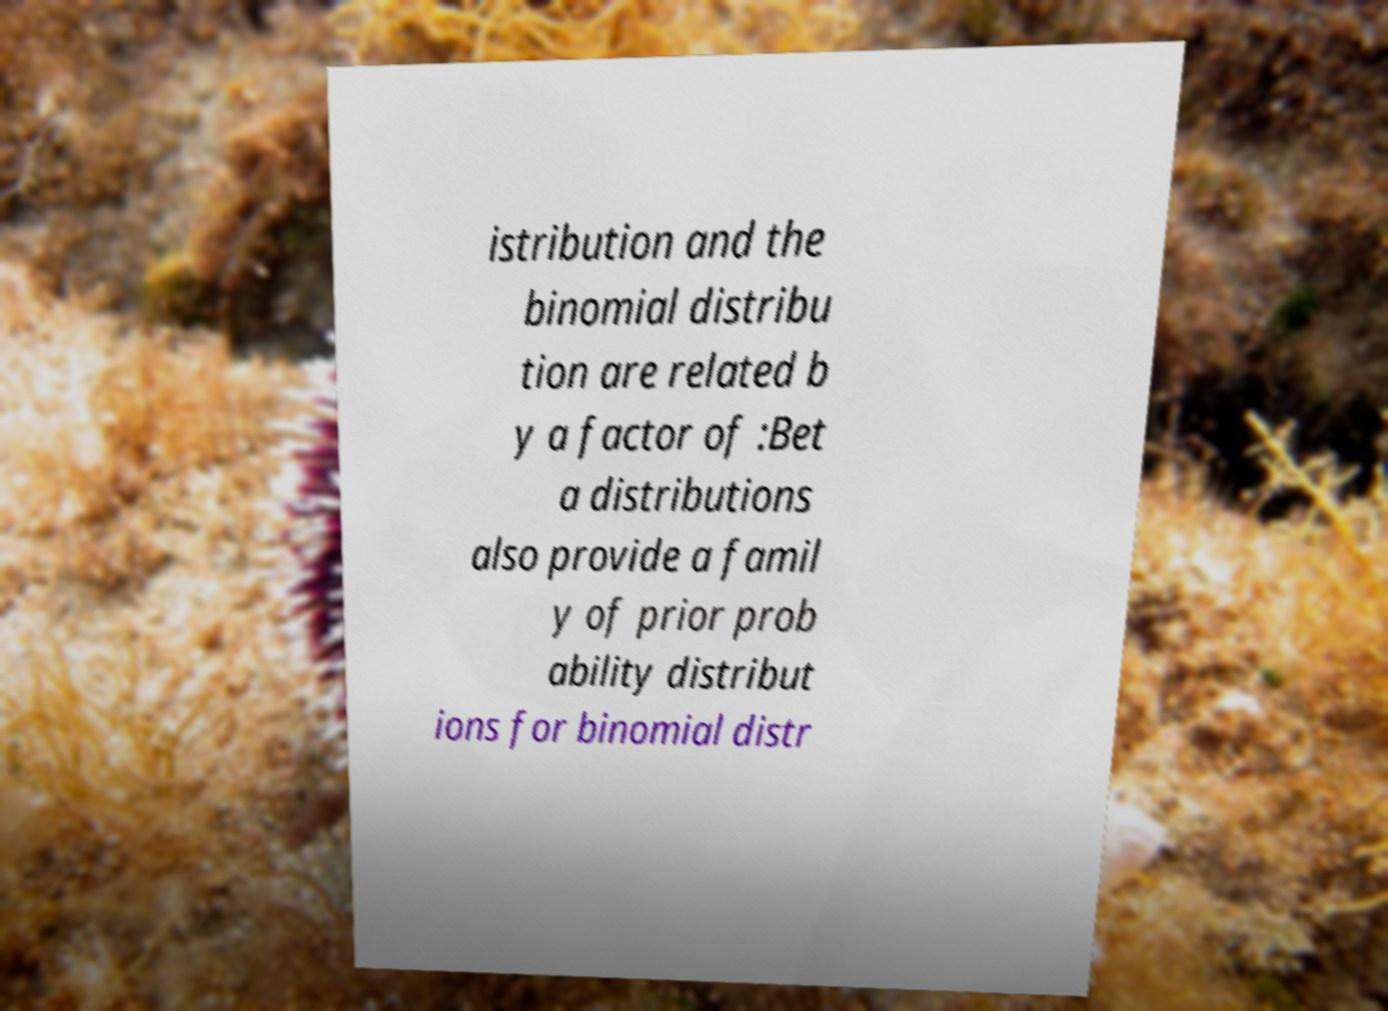Could you extract and type out the text from this image? istribution and the binomial distribu tion are related b y a factor of :Bet a distributions also provide a famil y of prior prob ability distribut ions for binomial distr 